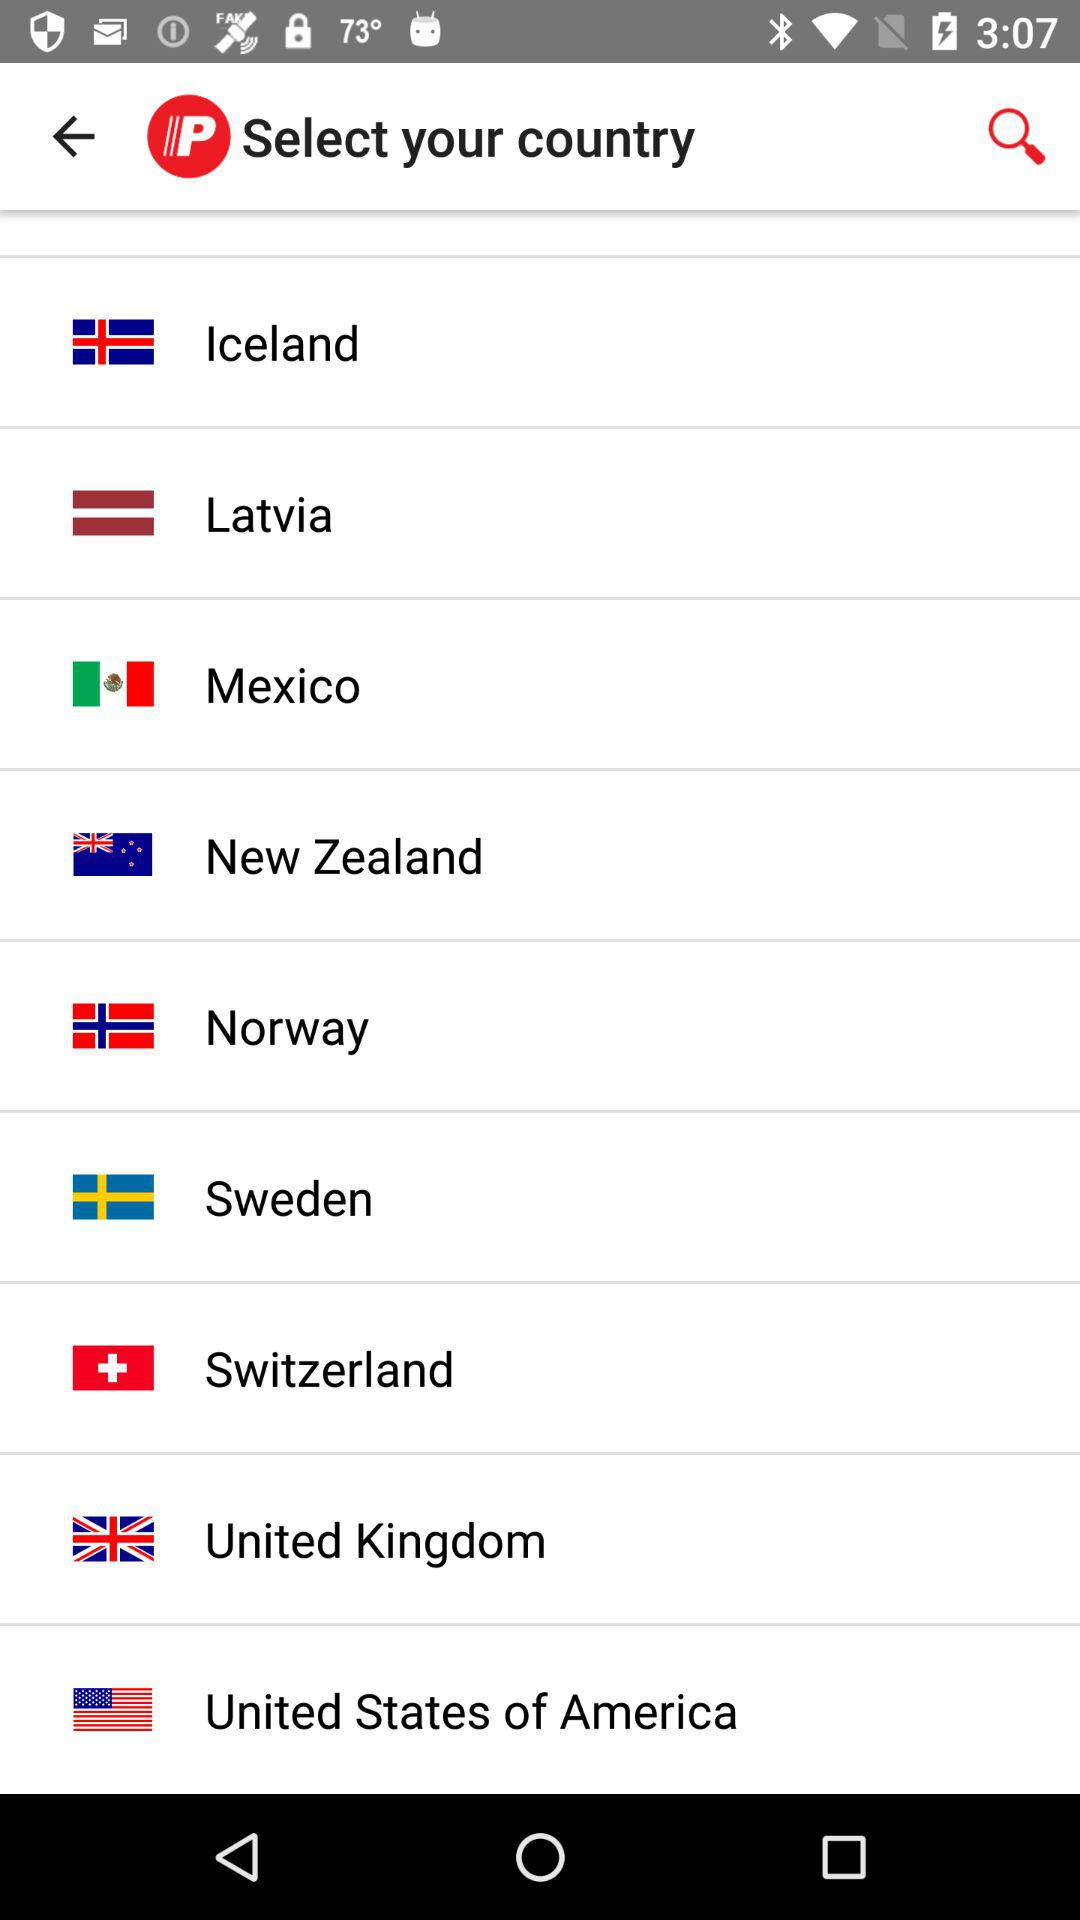Which country is selected?
When the provided information is insufficient, respond with <no answer>. <no answer> 